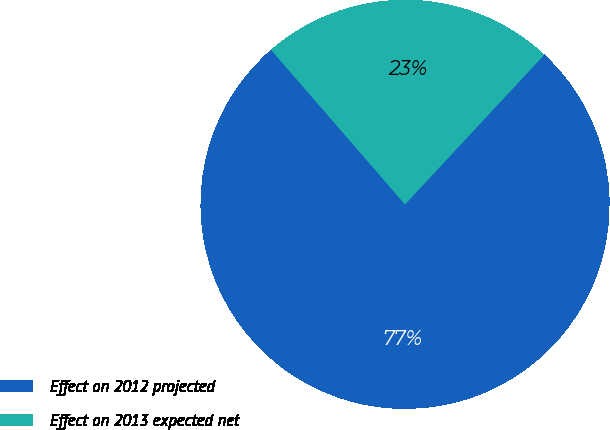Convert chart. <chart><loc_0><loc_0><loc_500><loc_500><pie_chart><fcel>Effect on 2012 projected<fcel>Effect on 2013 expected net<nl><fcel>76.71%<fcel>23.29%<nl></chart> 